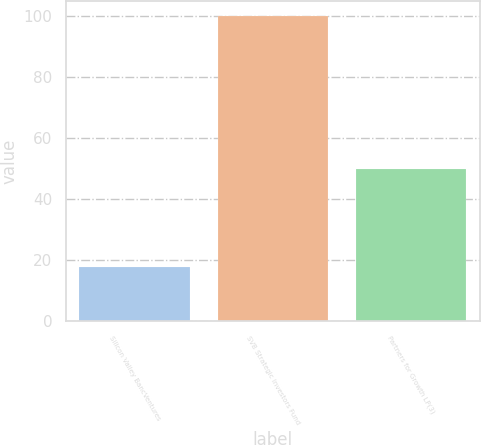<chart> <loc_0><loc_0><loc_500><loc_500><bar_chart><fcel>Silicon Valley BancVentures<fcel>SVB Strategic Investors Fund<fcel>Partners for Growth LP(3)<nl><fcel>17.74<fcel>100<fcel>50<nl></chart> 